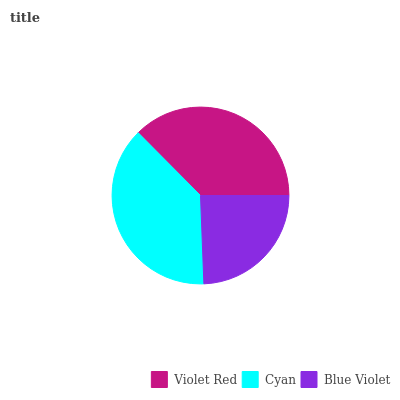Is Blue Violet the minimum?
Answer yes or no. Yes. Is Cyan the maximum?
Answer yes or no. Yes. Is Cyan the minimum?
Answer yes or no. No. Is Blue Violet the maximum?
Answer yes or no. No. Is Cyan greater than Blue Violet?
Answer yes or no. Yes. Is Blue Violet less than Cyan?
Answer yes or no. Yes. Is Blue Violet greater than Cyan?
Answer yes or no. No. Is Cyan less than Blue Violet?
Answer yes or no. No. Is Violet Red the high median?
Answer yes or no. Yes. Is Violet Red the low median?
Answer yes or no. Yes. Is Cyan the high median?
Answer yes or no. No. Is Cyan the low median?
Answer yes or no. No. 